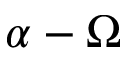<formula> <loc_0><loc_0><loc_500><loc_500>\alpha - \Omega</formula> 